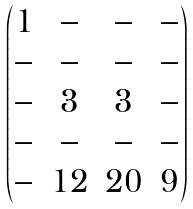<formula> <loc_0><loc_0><loc_500><loc_500>\begin{pmatrix} 1 & - & - & - \\ - & - & - & - \\ - & 3 & 3 & - \\ - & - & - & - \\ - & 1 2 & 2 0 & 9 \end{pmatrix}</formula> 